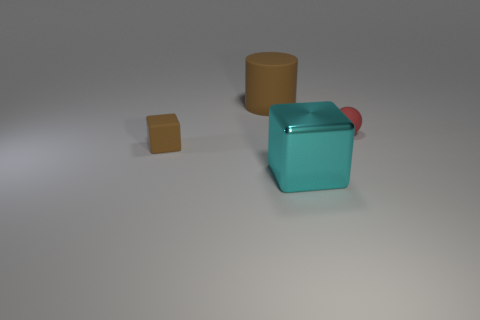Subtract all brown blocks. How many blocks are left? 1 Add 4 tiny rubber blocks. How many tiny rubber blocks are left? 5 Add 2 brown cylinders. How many brown cylinders exist? 3 Add 1 tiny green shiny spheres. How many objects exist? 5 Subtract 0 green cubes. How many objects are left? 4 Subtract all cylinders. How many objects are left? 3 Subtract 1 blocks. How many blocks are left? 1 Subtract all red cubes. Subtract all green balls. How many cubes are left? 2 Subtract all green cubes. How many blue cylinders are left? 0 Subtract all small cubes. Subtract all red matte blocks. How many objects are left? 3 